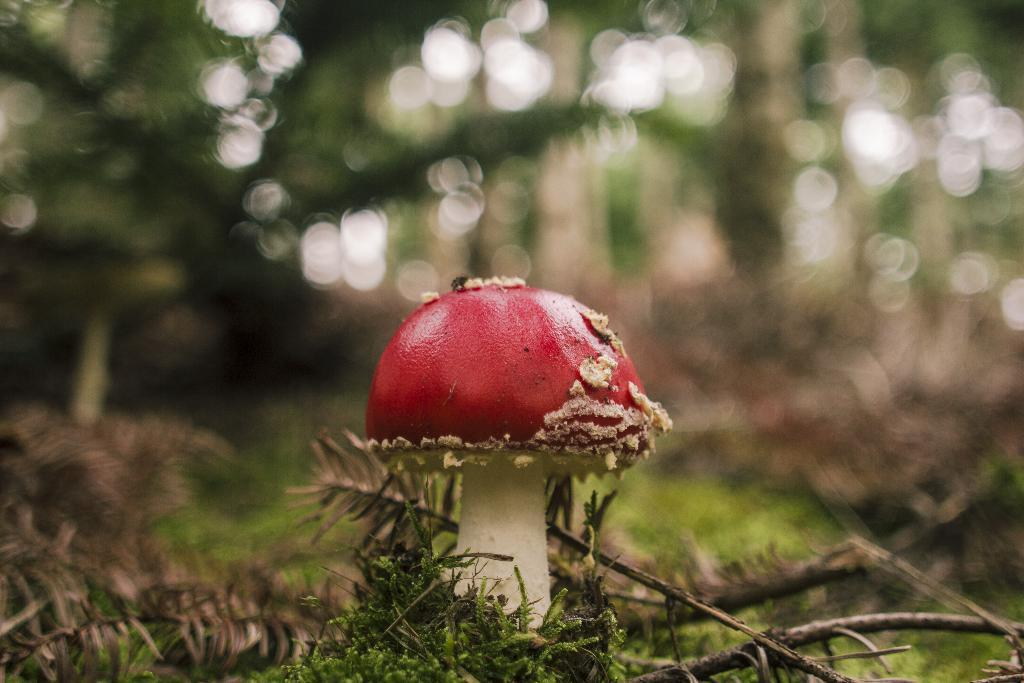What is the main subject of the picture? The main subject of the picture is a mushroom. What type of vegetation is present in the image? There is grass in the picture. Can you describe the background of the image? The background of the image is blurred. Where is the basin located in the image? There is no basin present in the image. What type of string is attached to the mushroom in the image? There is no string attached to the mushroom in the image. 